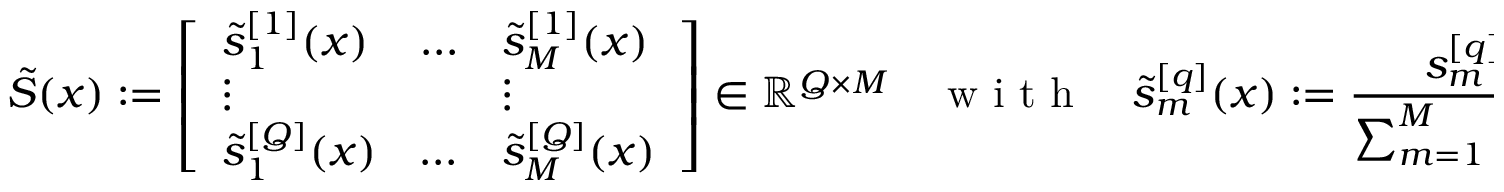Convert formula to latex. <formula><loc_0><loc_0><loc_500><loc_500>\tilde { S } ( x ) \colon = \left [ \begin{array} { l l l } { \tilde { s } _ { 1 } ^ { [ 1 ] } ( x ) } & { \dots } & { \tilde { s } _ { M } ^ { [ 1 ] } ( x ) } \\ { \vdots } & { \vdots } \\ { \tilde { s } _ { 1 } ^ { [ Q ] } ( x ) } & { \dots } & { \tilde { s } _ { M } ^ { [ Q ] } ( x ) } \end{array} \right ] \in \mathbb { R } ^ { Q \times M } \quad w i t h \quad \tilde { s } _ { m } ^ { [ q ] } ( x ) \colon = \frac { s _ { m } ^ { [ q ] } \zeta _ { m } ( x ) } { \sum _ { m = 1 } ^ { M } s _ { m } ^ { [ q ] } \zeta _ { m } ( x ) } .</formula> 